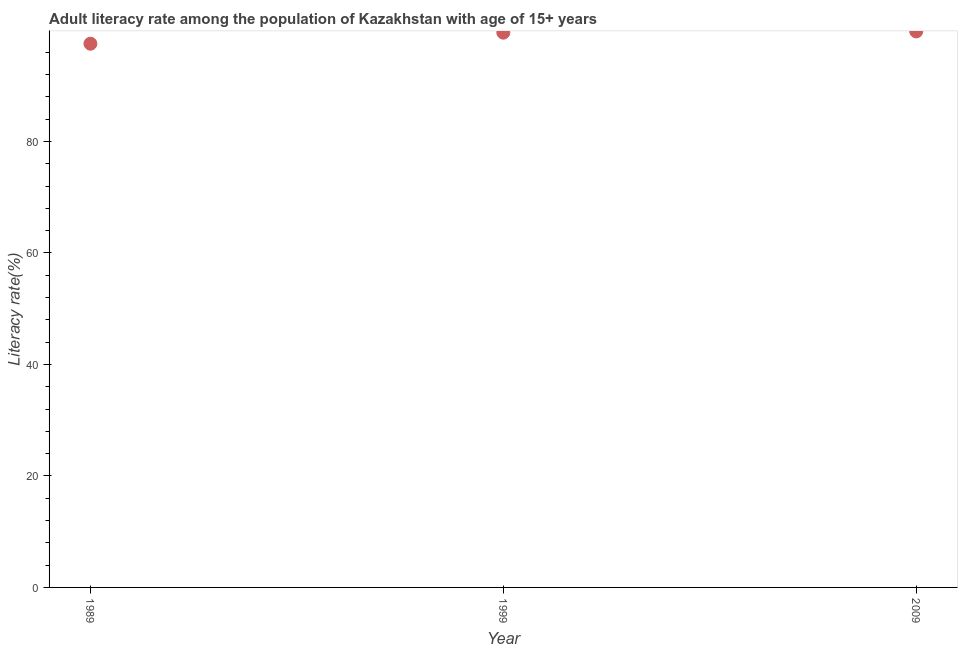What is the adult literacy rate in 2009?
Keep it short and to the point. 99.73. Across all years, what is the maximum adult literacy rate?
Provide a short and direct response. 99.73. Across all years, what is the minimum adult literacy rate?
Offer a terse response. 97.53. In which year was the adult literacy rate minimum?
Provide a short and direct response. 1989. What is the sum of the adult literacy rate?
Keep it short and to the point. 296.77. What is the difference between the adult literacy rate in 1999 and 2009?
Provide a succinct answer. -0.22. What is the average adult literacy rate per year?
Provide a succinct answer. 98.92. What is the median adult literacy rate?
Your answer should be very brief. 99.51. What is the ratio of the adult literacy rate in 1999 to that in 2009?
Offer a terse response. 1. Is the adult literacy rate in 1989 less than that in 1999?
Ensure brevity in your answer.  Yes. What is the difference between the highest and the second highest adult literacy rate?
Offer a very short reply. 0.22. What is the difference between the highest and the lowest adult literacy rate?
Provide a succinct answer. 2.2. How many years are there in the graph?
Provide a short and direct response. 3. Does the graph contain grids?
Make the answer very short. No. What is the title of the graph?
Your answer should be compact. Adult literacy rate among the population of Kazakhstan with age of 15+ years. What is the label or title of the X-axis?
Keep it short and to the point. Year. What is the label or title of the Y-axis?
Offer a terse response. Literacy rate(%). What is the Literacy rate(%) in 1989?
Offer a terse response. 97.53. What is the Literacy rate(%) in 1999?
Your answer should be compact. 99.51. What is the Literacy rate(%) in 2009?
Offer a terse response. 99.73. What is the difference between the Literacy rate(%) in 1989 and 1999?
Offer a very short reply. -1.98. What is the difference between the Literacy rate(%) in 1989 and 2009?
Give a very brief answer. -2.2. What is the difference between the Literacy rate(%) in 1999 and 2009?
Offer a terse response. -0.22. What is the ratio of the Literacy rate(%) in 1989 to that in 1999?
Your answer should be very brief. 0.98. What is the ratio of the Literacy rate(%) in 1989 to that in 2009?
Your response must be concise. 0.98. What is the ratio of the Literacy rate(%) in 1999 to that in 2009?
Your answer should be compact. 1. 